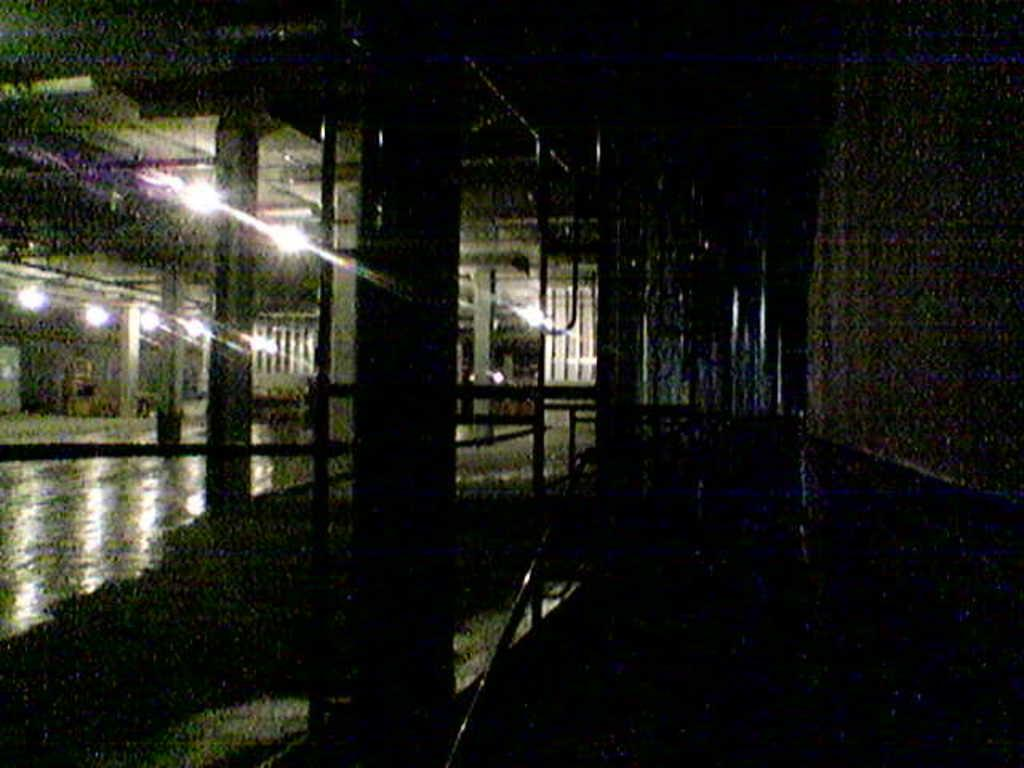What type of structure can be seen in the image? There is a wall in the image. What is present on the ceiling in the image? There are lights on the ceiling. What is located in the center of the image? There is a pillar in the center of the image. What is beside the pillar in the image? There is a railing beside the pillar. What time does the clock show in the image? There is no clock present in the image. What type of powder can be seen on the floor in the image? There is no powder visible on the floor in the image. 